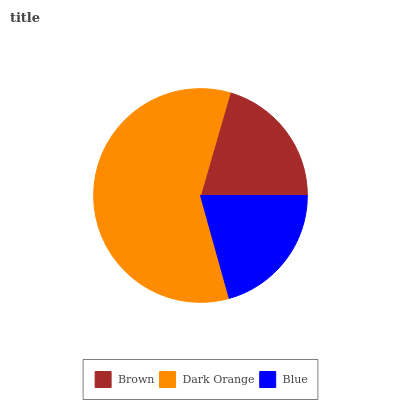Is Brown the minimum?
Answer yes or no. Yes. Is Dark Orange the maximum?
Answer yes or no. Yes. Is Blue the minimum?
Answer yes or no. No. Is Blue the maximum?
Answer yes or no. No. Is Dark Orange greater than Blue?
Answer yes or no. Yes. Is Blue less than Dark Orange?
Answer yes or no. Yes. Is Blue greater than Dark Orange?
Answer yes or no. No. Is Dark Orange less than Blue?
Answer yes or no. No. Is Blue the high median?
Answer yes or no. Yes. Is Blue the low median?
Answer yes or no. Yes. Is Dark Orange the high median?
Answer yes or no. No. Is Brown the low median?
Answer yes or no. No. 